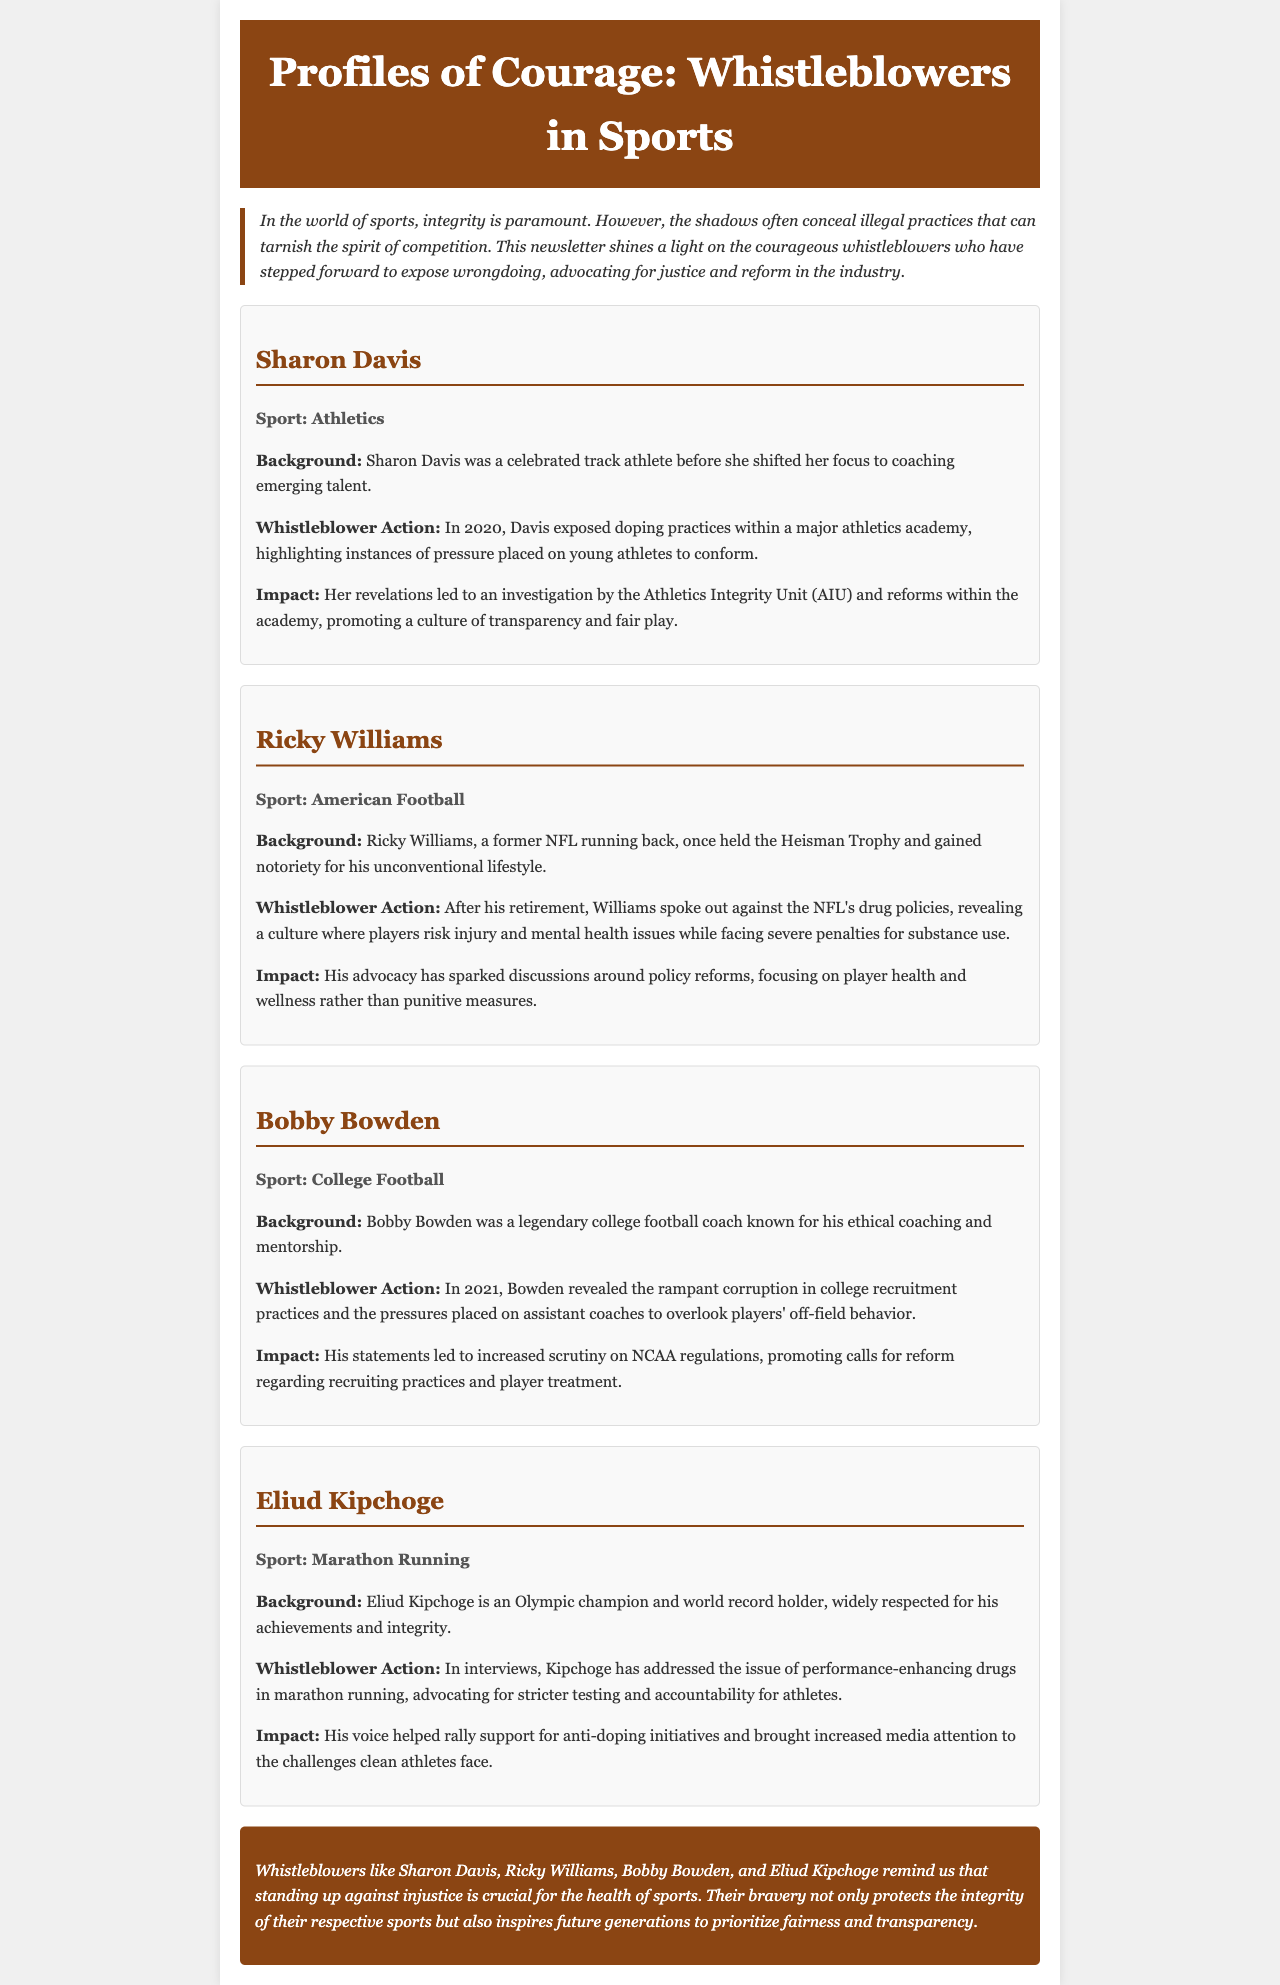What sport does Sharon Davis participate in? The document states that Sharon Davis is associated with athletics, as mentioned in her profile section.
Answer: Athletics In which year did Sharon Davis expose doping practices? The document explicitly mentions that Davis exposed doping practices in the year 2020.
Answer: 2020 What award did Ricky Williams hold? The document notes that Ricky Williams once held the Heisman Trophy, as indicated in his background.
Answer: Heisman Trophy What issue did Bobby Bowden address in 2021? The document specifies that Bobby Bowden revealed rampant corruption in college recruitment practices in 2021.
Answer: Rampant corruption Which athlete addressed performance-enhancing drugs in marathon running? Eliud Kipchoge is the athlete who addressed the issue of performance-enhancing drugs, as per his profile.
Answer: Eliud Kipchoge What impact did Sharon Davis' revelations have? The document states that her revelations led to an investigation by the Athletics Integrity Unit (AIU) and reforms within the academy.
Answer: Investigation by AIU How has Ricky Williams influenced NFL policies? His advocacy has sparked discussions around policy reforms focusing on player health and wellness rather than punitive measures.
Answer: Policy reforms What is a common theme among all the profiles featured? The document highlights that the common theme is standing up against illegal practices and advocating for justice in sports.
Answer: Standing up against illegal practices What do the whistleblowers remind us about the integrity of sports? The document concludes that these whistleblowers remind us that standing up against injustice is crucial for the health of sports.
Answer: Crucial for the health of sports 